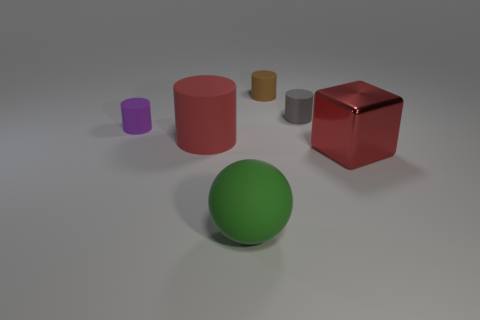Subtract all small purple matte cylinders. How many cylinders are left? 3 Subtract all purple cylinders. How many cylinders are left? 3 Add 1 small gray rubber things. How many objects exist? 7 Subtract 1 spheres. How many spheres are left? 0 Add 6 big shiny blocks. How many big shiny blocks are left? 7 Add 4 large green cubes. How many large green cubes exist? 4 Subtract 0 cyan balls. How many objects are left? 6 Subtract all balls. How many objects are left? 5 Subtract all red spheres. Subtract all green blocks. How many spheres are left? 1 Subtract all yellow balls. How many brown cylinders are left? 1 